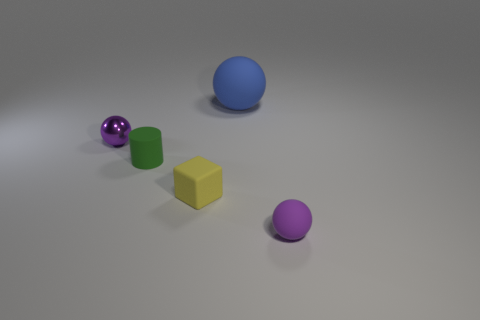How many purple matte spheres have the same size as the yellow rubber thing?
Your answer should be very brief. 1. What number of small purple objects are left of the purple sphere that is right of the tiny green rubber thing?
Offer a very short reply. 1. Is the tiny purple sphere on the left side of the large object made of the same material as the small cylinder?
Make the answer very short. No. Does the tiny purple thing behind the purple matte thing have the same material as the small purple object to the right of the green rubber thing?
Your answer should be compact. No. Is the number of purple metallic spheres behind the tiny purple metal object greater than the number of purple objects?
Provide a short and direct response. No. The rubber sphere that is to the right of the rubber sphere that is behind the green matte object is what color?
Make the answer very short. Purple. There is a yellow object that is the same size as the green cylinder; what is its shape?
Your answer should be very brief. Cube. What shape is the other small object that is the same color as the shiny object?
Your answer should be very brief. Sphere. Is the number of purple balls that are in front of the yellow object the same as the number of tiny matte balls?
Your answer should be very brief. Yes. What is the material of the purple object that is right of the tiny sphere that is behind the small purple thing to the right of the small block?
Offer a very short reply. Rubber. 